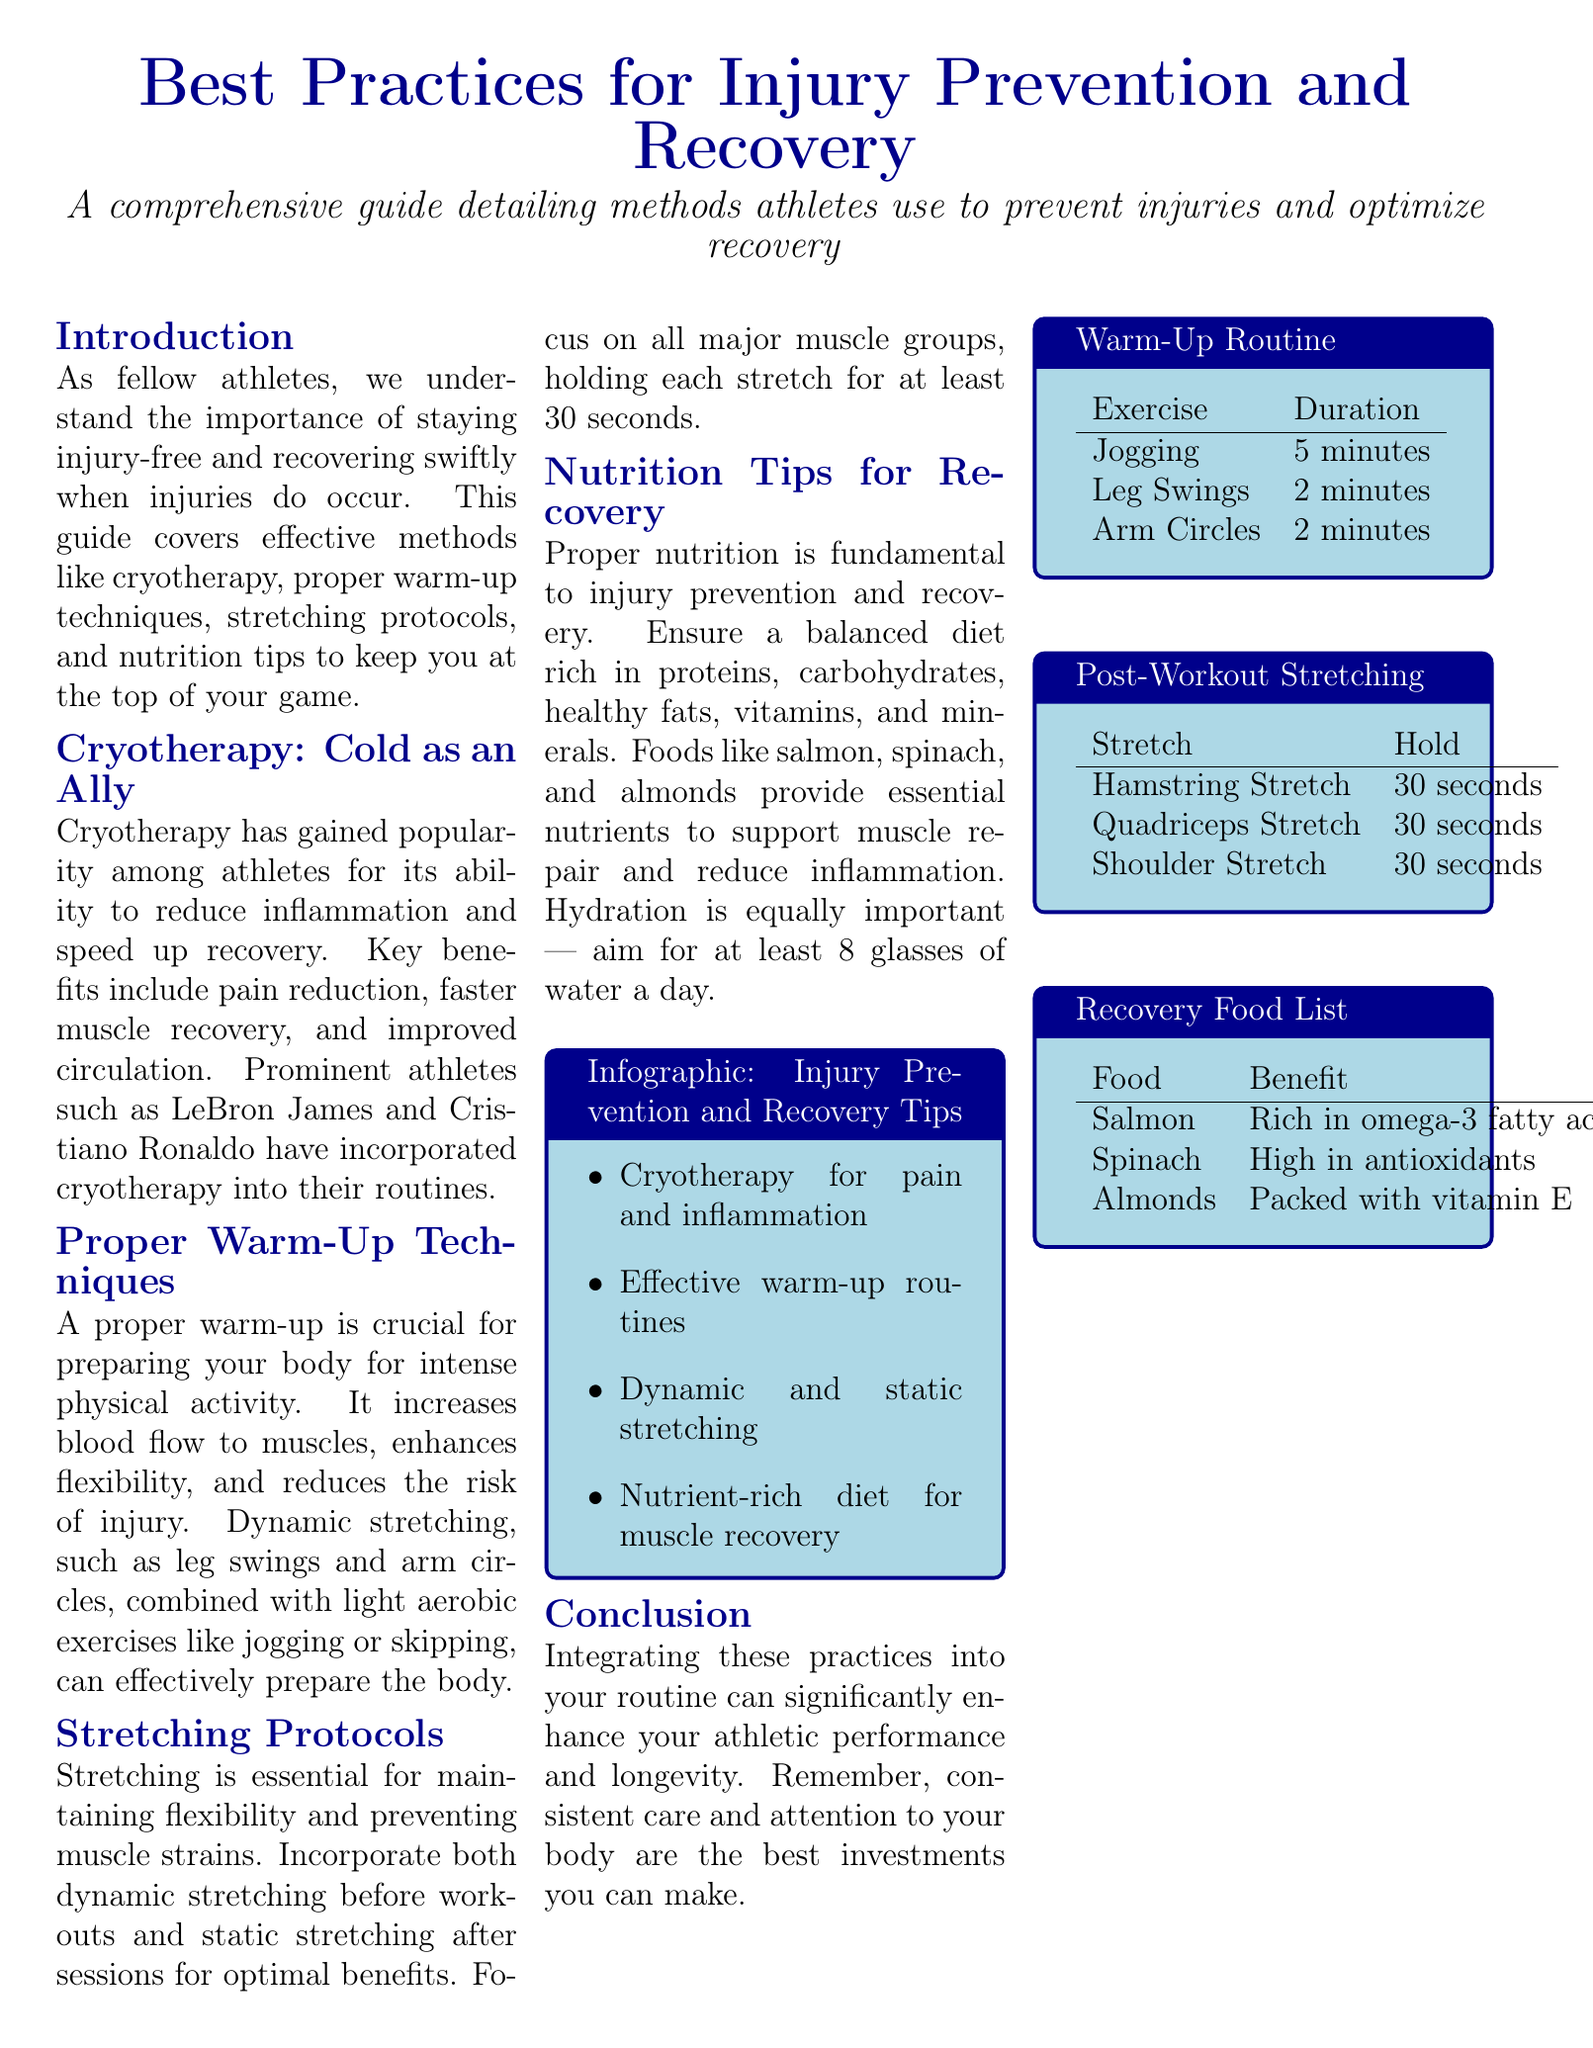What is the main purpose of the guide? The guide aims to provide methods athletes use to prevent injuries and optimize recovery.
Answer: Injury prevention and recovery Who are some prominent athletes mentioned that use cryotherapy? The document mentions LeBron James and Cristiano Ronaldo as athletes who use cryotherapy.
Answer: LeBron James and Cristiano Ronaldo What are the benefits of cryotherapy listed in the document? Key benefits include pain reduction, faster muscle recovery, and improved circulation.
Answer: Pain reduction, faster muscle recovery, improved circulation How long should you hold each stretch after workouts? The document states that each stretch should be held for at least 30 seconds.
Answer: 30 seconds What type of food is recommended for muscle recovery? The document lists salmon, spinach, and almonds as beneficial for muscle recovery.
Answer: Salmon, spinach, and almonds Which warm-up exercise lasts 5 minutes according to the warm-up routine? The warm-up routine specifies that jogging lasts 5 minutes.
Answer: Jogging How many glasses of water is it recommended to drink per day? The document suggests aiming for at least 8 glasses of water a day.
Answer: 8 glasses What type of stretching should be done before workouts? The document advises incorporating dynamic stretching before workouts.
Answer: Dynamic stretching What is included in the infographic section? The infographic section includes tips such as cryotherapy for pain and inflammation and effective warm-up routines.
Answer: Cryotherapy for pain and inflammation, effective warm-up routines, dynamic and static stretching, nutrient-rich diet for muscle recovery 